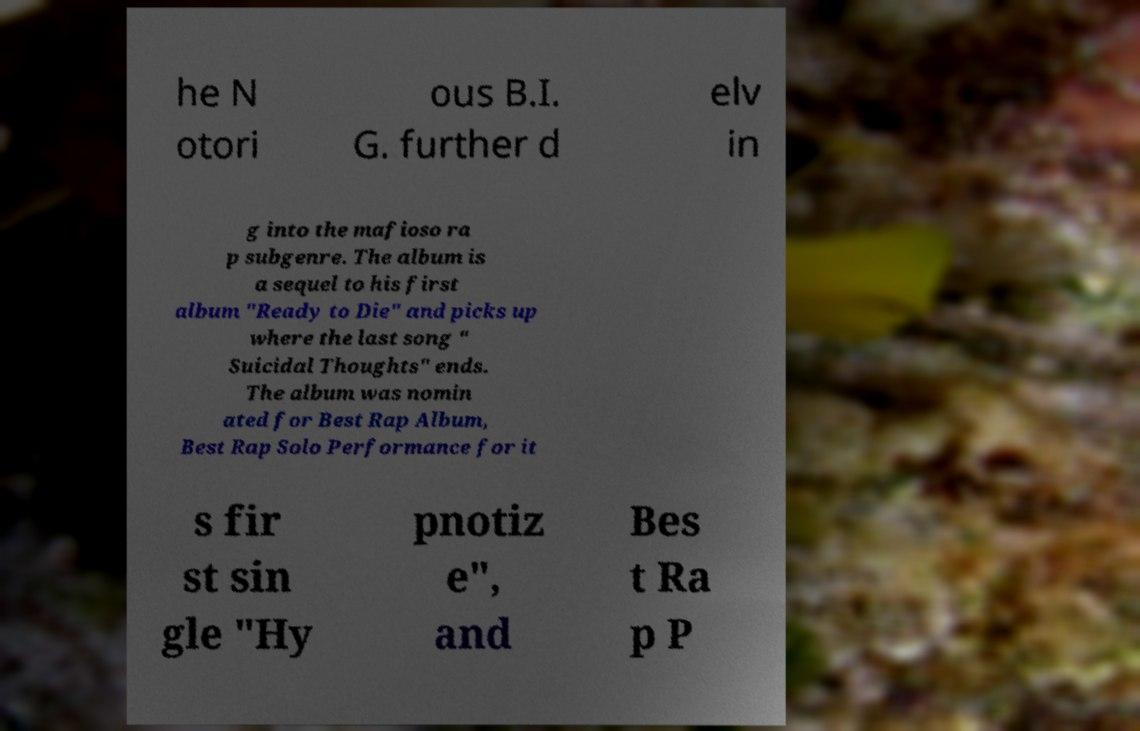I need the written content from this picture converted into text. Can you do that? he N otori ous B.I. G. further d elv in g into the mafioso ra p subgenre. The album is a sequel to his first album "Ready to Die" and picks up where the last song " Suicidal Thoughts" ends. The album was nomin ated for Best Rap Album, Best Rap Solo Performance for it s fir st sin gle "Hy pnotiz e", and Bes t Ra p P 